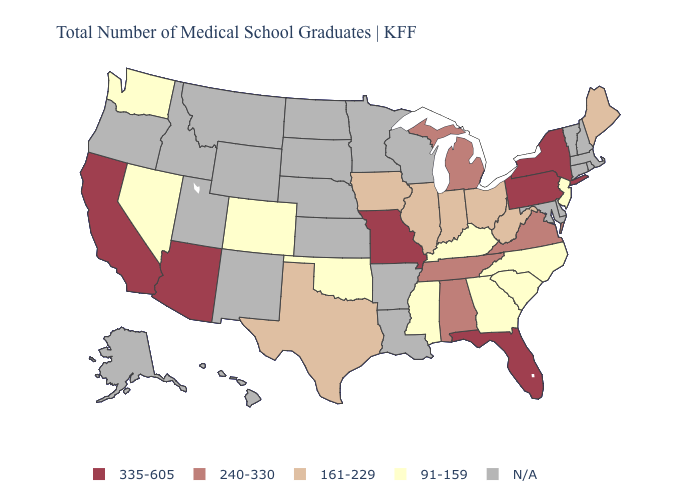What is the lowest value in states that border Arizona?
Answer briefly. 91-159. What is the lowest value in states that border Idaho?
Be succinct. 91-159. Does the map have missing data?
Keep it brief. Yes. Name the states that have a value in the range 161-229?
Keep it brief. Illinois, Indiana, Iowa, Maine, Ohio, Texas, West Virginia. Which states hav the highest value in the Northeast?
Give a very brief answer. New York, Pennsylvania. Name the states that have a value in the range N/A?
Quick response, please. Alaska, Arkansas, Connecticut, Delaware, Hawaii, Idaho, Kansas, Louisiana, Maryland, Massachusetts, Minnesota, Montana, Nebraska, New Hampshire, New Mexico, North Dakota, Oregon, Rhode Island, South Dakota, Utah, Vermont, Wisconsin, Wyoming. Name the states that have a value in the range 335-605?
Keep it brief. Arizona, California, Florida, Missouri, New York, Pennsylvania. What is the value of Texas?
Be succinct. 161-229. What is the highest value in the USA?
Short answer required. 335-605. Among the states that border Delaware , which have the highest value?
Keep it brief. Pennsylvania. Among the states that border Indiana , does Kentucky have the lowest value?
Short answer required. Yes. How many symbols are there in the legend?
Be succinct. 5. Does Nevada have the highest value in the West?
Answer briefly. No. Name the states that have a value in the range 161-229?
Concise answer only. Illinois, Indiana, Iowa, Maine, Ohio, Texas, West Virginia. Name the states that have a value in the range N/A?
Give a very brief answer. Alaska, Arkansas, Connecticut, Delaware, Hawaii, Idaho, Kansas, Louisiana, Maryland, Massachusetts, Minnesota, Montana, Nebraska, New Hampshire, New Mexico, North Dakota, Oregon, Rhode Island, South Dakota, Utah, Vermont, Wisconsin, Wyoming. 